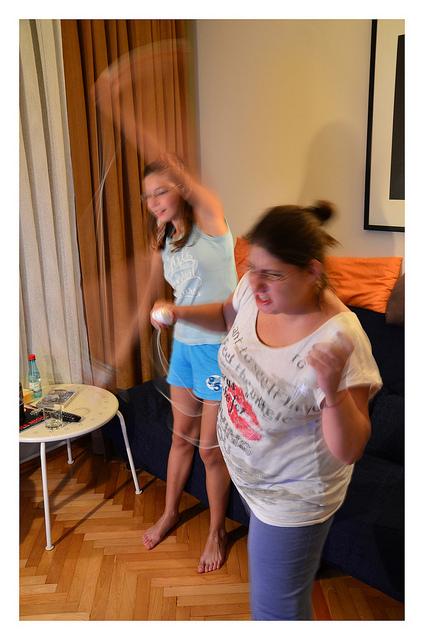How many people are there?
Be succinct. 2. What are the women holding?
Write a very short answer. Wii controllers. What video game system are these women playing with?
Answer briefly. Wii. 